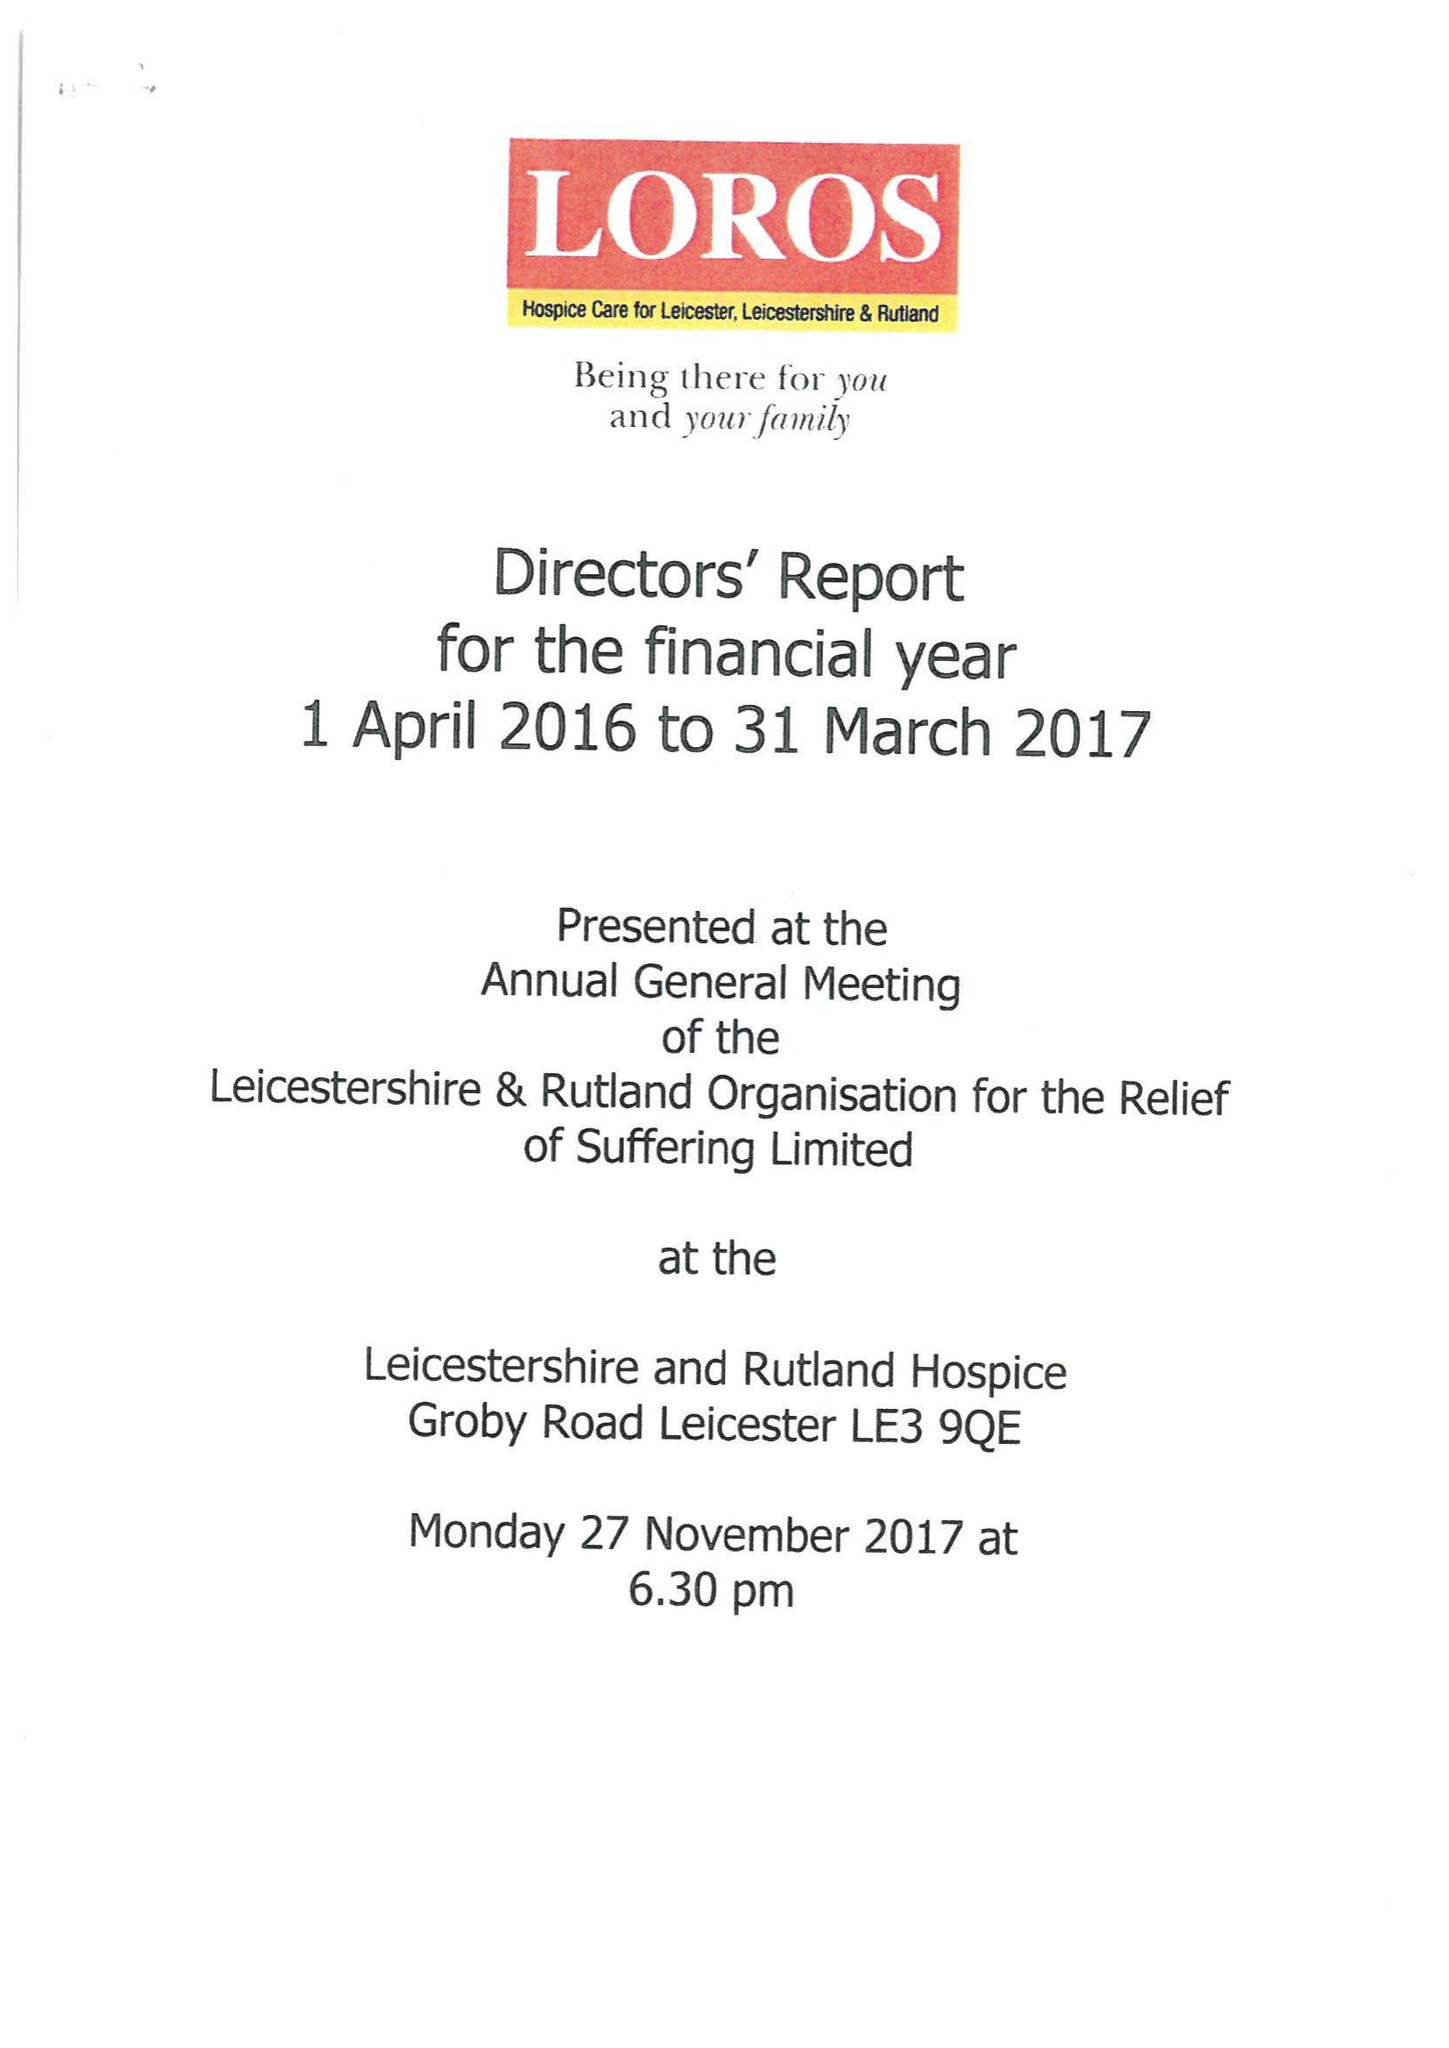What is the value for the spending_annually_in_british_pounds?
Answer the question using a single word or phrase. 12670232.00 